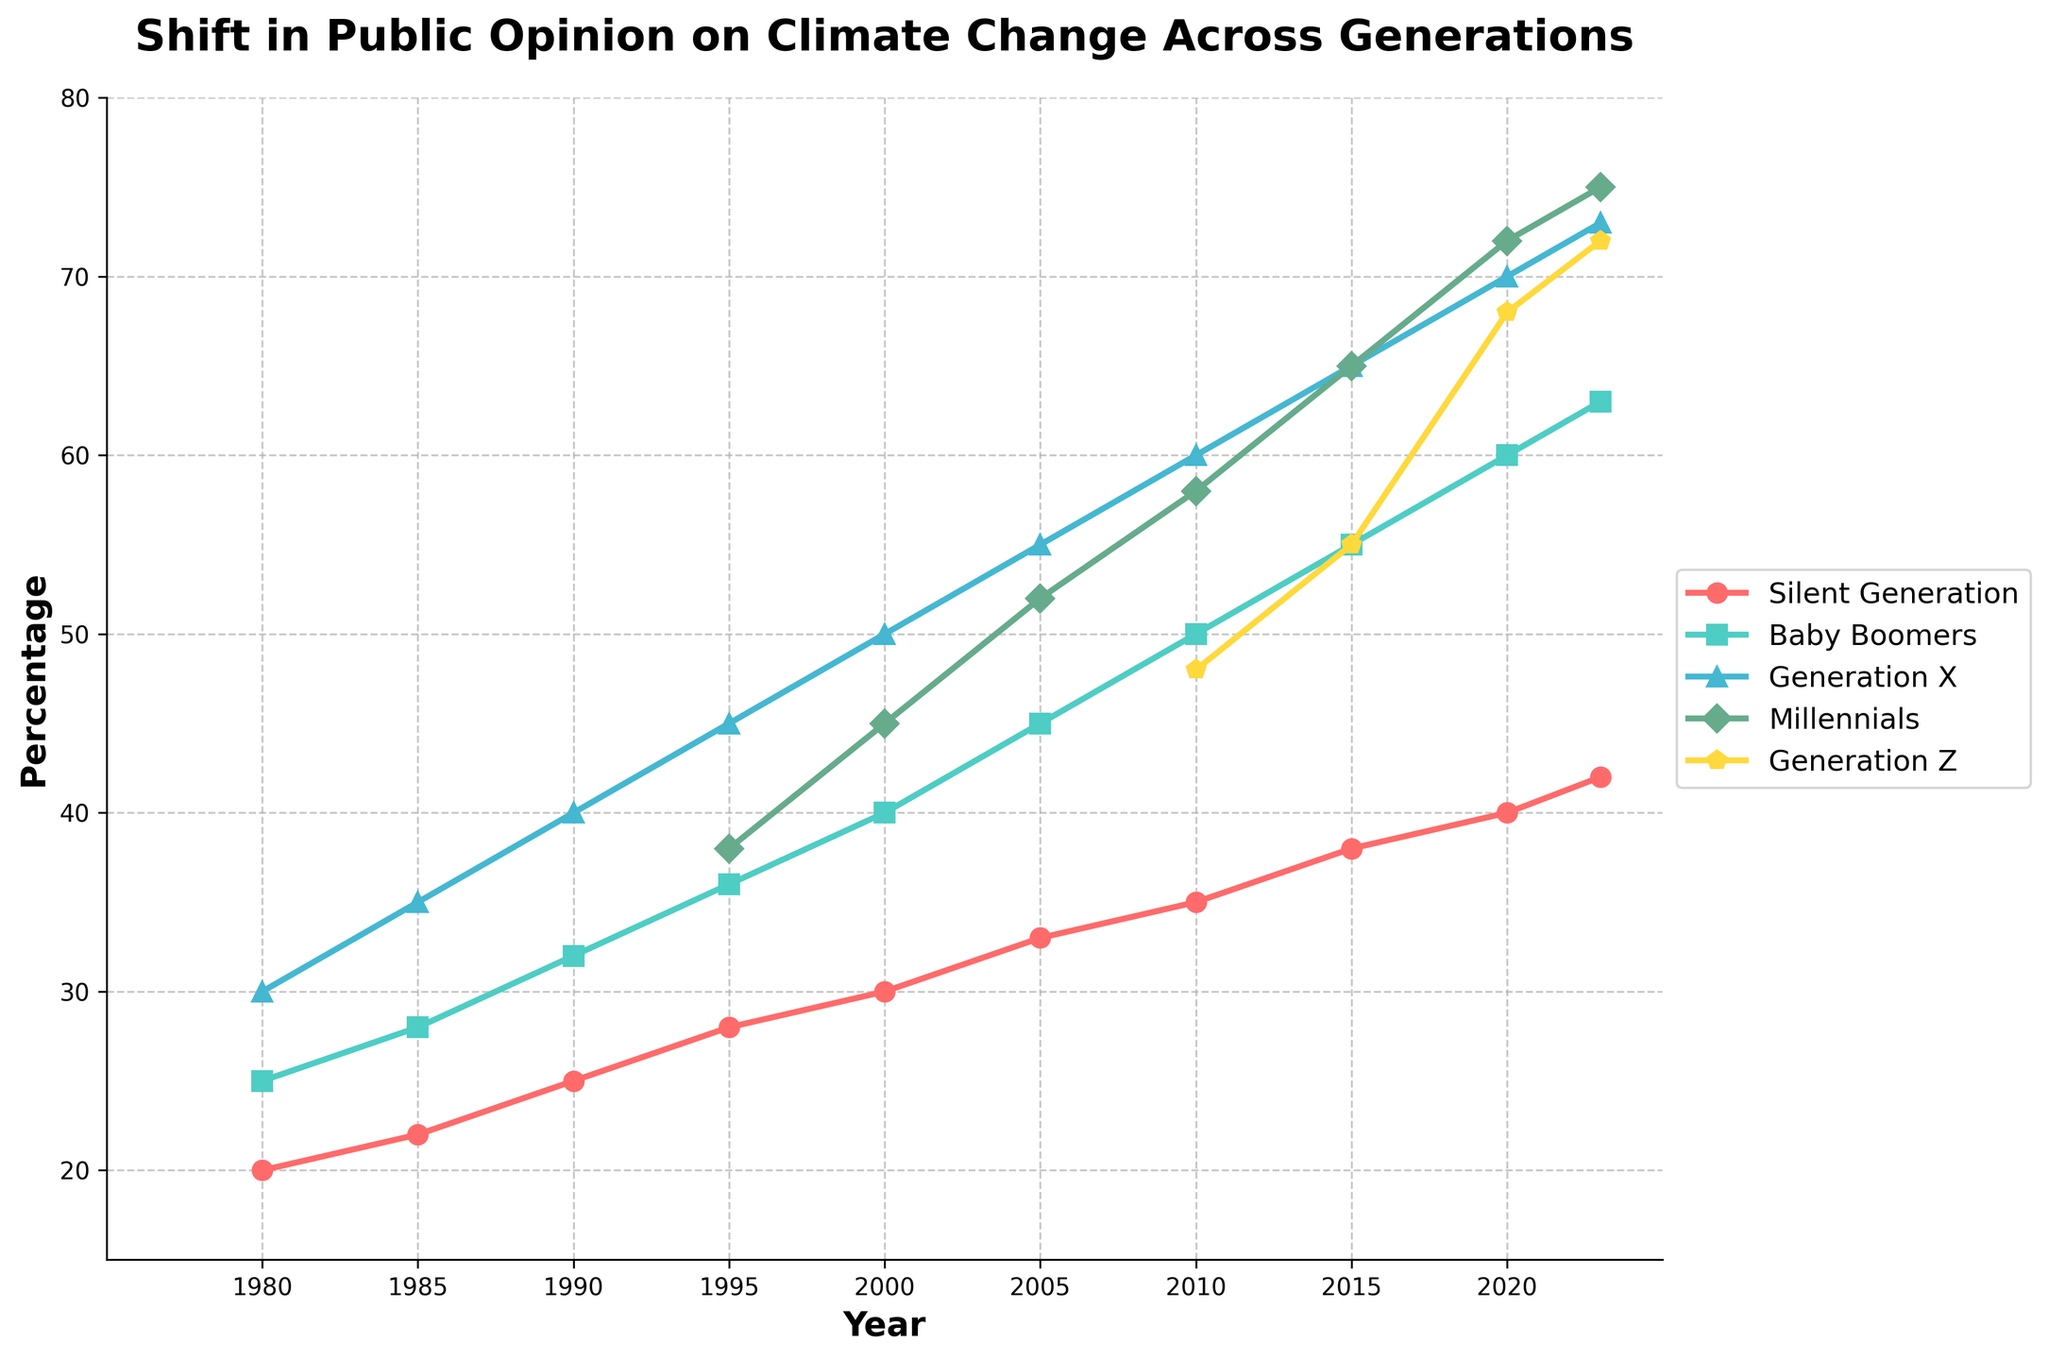What general trend can be observed across all generations over the years? All generational lines show an upward trend, indicating that public opinion has increasingly recognized the importance of climate change from 1980 to 2023.
Answer: Upward trend Which generation has the steepest increase in the percentage of people recognizing climate change from 1980 to 2023? By comparing the slopes of the lines, Generation X shows the steepest increase from around 30% in 1980 to 73% in 2023.
Answer: Generation X In which year did Millennials surpass Baby Boomers in their concern for climate change? Millennials surpassed Baby Boomers in 2005, where Millennials had 52% while Baby Boomers had 45%.
Answer: 2005 What's the percentage difference between Generation Z and Silent Generation in 2023? Generation Z has 72% while Silent Generation has 42% in 2023. The difference is 72 - 42 = 30%.
Answer: 30% Which generation had the largest increase in percentage points from 1985 to 2020? Baby Boomers increased from 28% in 1985 to 60% in 2020, an increase of 60 - 28 = 32 percentage points. This is larger than any other generational increase in the same period.
Answer: Baby Boomers What visual characteristics identify the line representing Generation Z? The line for Generation Z uses a green color and penta-star markers, starting at 48% in 2010 and rising to 72% in 2023.
Answer: Green color with penta-star markers How much ahead is Generation X compared to Baby Boomers in 2023? Generation X is at 73%, and Baby Boomers are at 63% in 2023. The difference is 73 - 63 = 10%.
Answer: 10% By what percentage did the Silent Generation's concern about climate change increase from 2010 to 2023? The Silent Generation's percentage increased from 35% in 2010 to 42% in 2023. The difference is 42 - 35 = 7%.
Answer: 7% Compare the slope of the line representing Millennials between 1990 to 2010 with Generation Z between 2010 to 2023. Which one is steeper? The Millennials increased from 0% to 58% between 1990 and 2010, which is 58 percentage points over 20 years (slope = 2.9). Generation Z increased from 48% to 72% between 2010 and 2023, which is 24 percentage points over 13 years (slope = 1.85). The Millennials' slope is steeper.
Answer: Millennials 